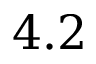Convert formula to latex. <formula><loc_0><loc_0><loc_500><loc_500>4 . 2</formula> 